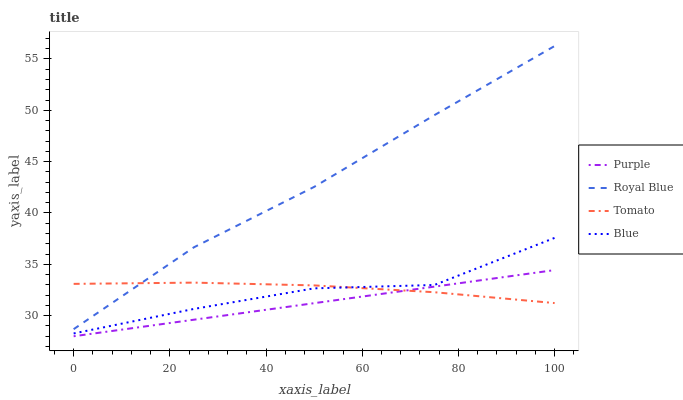Does Purple have the minimum area under the curve?
Answer yes or no. Yes. Does Royal Blue have the maximum area under the curve?
Answer yes or no. Yes. Does Tomato have the minimum area under the curve?
Answer yes or no. No. Does Tomato have the maximum area under the curve?
Answer yes or no. No. Is Purple the smoothest?
Answer yes or no. Yes. Is Blue the roughest?
Answer yes or no. Yes. Is Royal Blue the smoothest?
Answer yes or no. No. Is Royal Blue the roughest?
Answer yes or no. No. Does Purple have the lowest value?
Answer yes or no. Yes. Does Royal Blue have the lowest value?
Answer yes or no. No. Does Royal Blue have the highest value?
Answer yes or no. Yes. Does Tomato have the highest value?
Answer yes or no. No. Is Purple less than Blue?
Answer yes or no. Yes. Is Blue greater than Purple?
Answer yes or no. Yes. Does Tomato intersect Royal Blue?
Answer yes or no. Yes. Is Tomato less than Royal Blue?
Answer yes or no. No. Is Tomato greater than Royal Blue?
Answer yes or no. No. Does Purple intersect Blue?
Answer yes or no. No. 